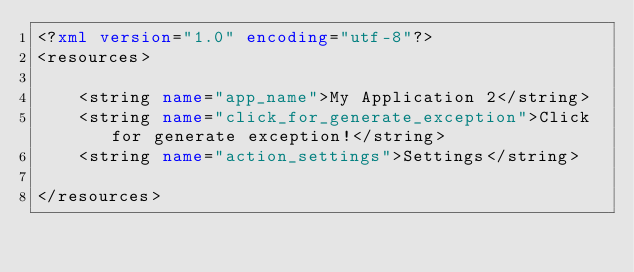Convert code to text. <code><loc_0><loc_0><loc_500><loc_500><_XML_><?xml version="1.0" encoding="utf-8"?>
<resources>

    <string name="app_name">My Application 2</string>
    <string name="click_for_generate_exception">Click for generate exception!</string>
    <string name="action_settings">Settings</string>

</resources>
</code> 